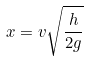<formula> <loc_0><loc_0><loc_500><loc_500>x = v \sqrt { \frac { h } { 2 g } }</formula> 